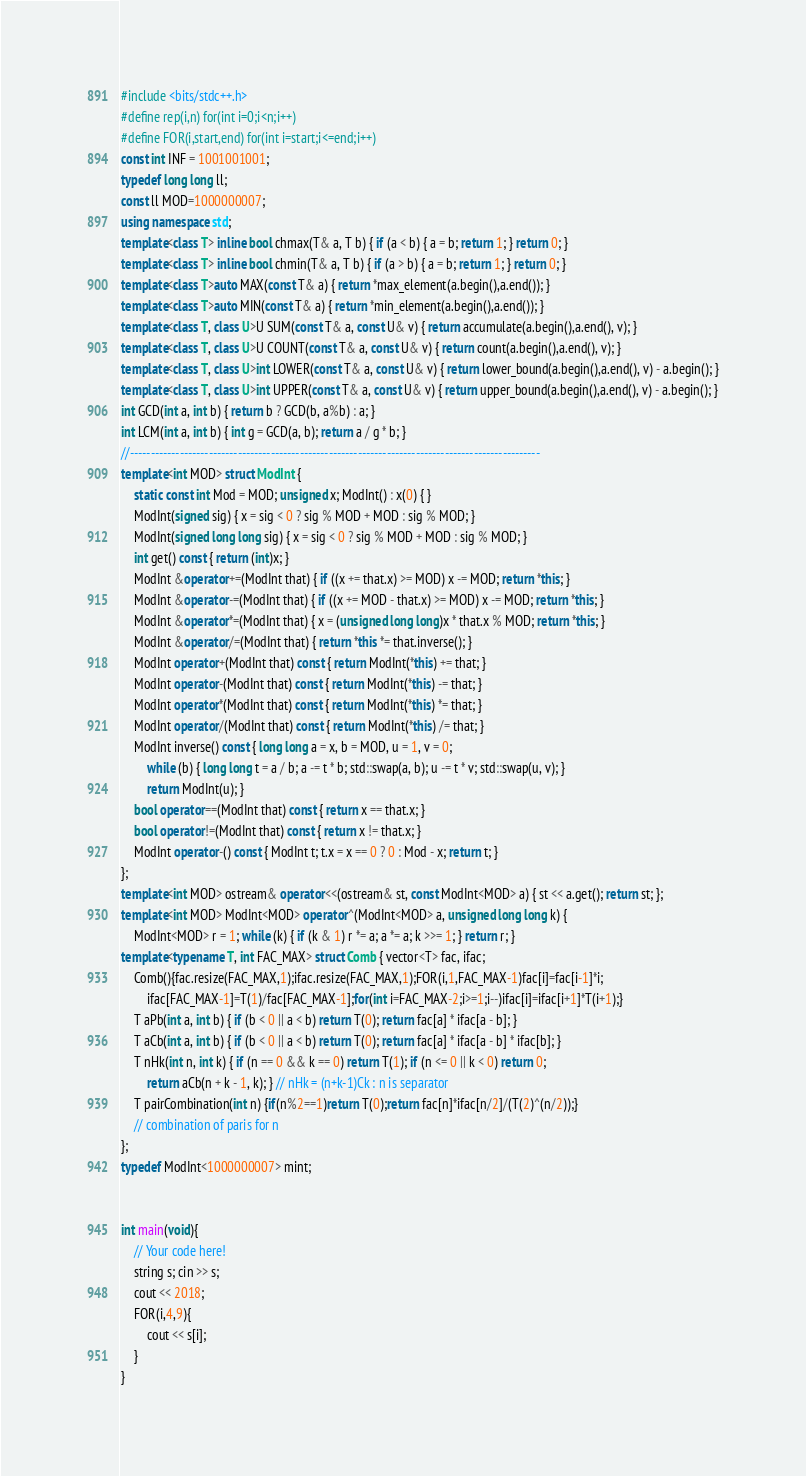Convert code to text. <code><loc_0><loc_0><loc_500><loc_500><_C++_>#include <bits/stdc++.h>
#define rep(i,n) for(int i=0;i<n;i++)
#define FOR(i,start,end) for(int i=start;i<=end;i++)
const int INF = 1001001001;
typedef long long ll;
const ll MOD=1000000007;
using namespace std;
template<class T> inline bool chmax(T& a, T b) { if (a < b) { a = b; return 1; } return 0; }
template<class T> inline bool chmin(T& a, T b) { if (a > b) { a = b; return 1; } return 0; }
template<class T>auto MAX(const T& a) { return *max_element(a.begin(),a.end()); }
template<class T>auto MIN(const T& a) { return *min_element(a.begin(),a.end()); }
template<class T, class U>U SUM(const T& a, const U& v) { return accumulate(a.begin(),a.end(), v); }
template<class T, class U>U COUNT(const T& a, const U& v) { return count(a.begin(),a.end(), v); }
template<class T, class U>int LOWER(const T& a, const U& v) { return lower_bound(a.begin(),a.end(), v) - a.begin(); }
template<class T, class U>int UPPER(const T& a, const U& v) { return upper_bound(a.begin(),a.end(), v) - a.begin(); }
int GCD(int a, int b) { return b ? GCD(b, a%b) : a; }
int LCM(int a, int b) { int g = GCD(a, b); return a / g * b; }
//---------------------------------------------------------------------------------------------------
template<int MOD> struct ModInt {
    static const int Mod = MOD; unsigned x; ModInt() : x(0) { }
    ModInt(signed sig) { x = sig < 0 ? sig % MOD + MOD : sig % MOD; }
    ModInt(signed long long sig) { x = sig < 0 ? sig % MOD + MOD : sig % MOD; }
    int get() const { return (int)x; }
    ModInt &operator+=(ModInt that) { if ((x += that.x) >= MOD) x -= MOD; return *this; }
    ModInt &operator-=(ModInt that) { if ((x += MOD - that.x) >= MOD) x -= MOD; return *this; }
    ModInt &operator*=(ModInt that) { x = (unsigned long long)x * that.x % MOD; return *this; }
    ModInt &operator/=(ModInt that) { return *this *= that.inverse(); }
    ModInt operator+(ModInt that) const { return ModInt(*this) += that; }
    ModInt operator-(ModInt that) const { return ModInt(*this) -= that; }
    ModInt operator*(ModInt that) const { return ModInt(*this) *= that; }
    ModInt operator/(ModInt that) const { return ModInt(*this) /= that; }
    ModInt inverse() const { long long a = x, b = MOD, u = 1, v = 0;
        while (b) { long long t = a / b; a -= t * b; std::swap(a, b); u -= t * v; std::swap(u, v); }
        return ModInt(u); }
    bool operator==(ModInt that) const { return x == that.x; }
    bool operator!=(ModInt that) const { return x != that.x; }
    ModInt operator-() const { ModInt t; t.x = x == 0 ? 0 : Mod - x; return t; }
};
template<int MOD> ostream& operator<<(ostream& st, const ModInt<MOD> a) { st << a.get(); return st; };
template<int MOD> ModInt<MOD> operator^(ModInt<MOD> a, unsigned long long k) {
    ModInt<MOD> r = 1; while (k) { if (k & 1) r *= a; a *= a; k >>= 1; } return r; }
template<typename T, int FAC_MAX> struct Comb { vector<T> fac, ifac;
    Comb(){fac.resize(FAC_MAX,1);ifac.resize(FAC_MAX,1);FOR(i,1,FAC_MAX-1)fac[i]=fac[i-1]*i;
        ifac[FAC_MAX-1]=T(1)/fac[FAC_MAX-1];for(int i=FAC_MAX-2;i>=1;i--)ifac[i]=ifac[i+1]*T(i+1);}
    T aPb(int a, int b) { if (b < 0 || a < b) return T(0); return fac[a] * ifac[a - b]; }
    T aCb(int a, int b) { if (b < 0 || a < b) return T(0); return fac[a] * ifac[a - b] * ifac[b]; }
    T nHk(int n, int k) { if (n == 0 && k == 0) return T(1); if (n <= 0 || k < 0) return 0;
        return aCb(n + k - 1, k); } // nHk = (n+k-1)Ck : n is separator
    T pairCombination(int n) {if(n%2==1)return T(0);return fac[n]*ifac[n/2]/(T(2)^(n/2));}
    // combination of paris for n
}; 
typedef ModInt<1000000007> mint;


int main(void){
    // Your code here!
    string s; cin >> s;
    cout << 2018;
    FOR(i,4,9){
        cout << s[i];
    }
}
</code> 